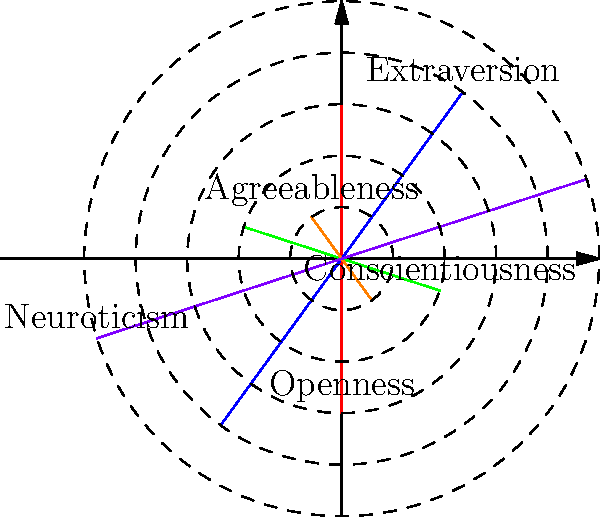In the given polar rose diagram representing the Big Five personality traits, which trait is represented by the largest petal, and what psychological implications might this have for an individual with such a prominent trait? To answer this question, we need to follow these steps:

1. Identify the traits represented in the diagram:
   The diagram shows five petals, each representing one of the Big Five personality traits:
   Openness, Conscientiousness, Extraversion, Agreeableness, and Neuroticism.

2. Determine the largest petal:
   By comparing the sizes of the petals, we can see that the purple petal, which represents Neuroticism, extends the furthest from the center and is therefore the largest.

3. Understand the implications of high Neuroticism:
   Neuroticism is associated with emotional instability and the tendency to experience negative emotions. A high score in Neuroticism might imply:

   a) Increased susceptibility to stress and anxiety
   b) Greater likelihood of experiencing mood swings
   c) Higher risk for developing mental health issues like depression or anxiety disorders
   d) Potentially more intense emotional responses to life events
   e) Possible difficulty in coping with challenging situations

4. Consider the professional implications:
   As a psychiatrist, recognizing a high Neuroticism score would be crucial for:

   a) Developing appropriate treatment plans
   b) Identifying potential risk factors for mental health issues
   c) Tailoring therapeutic approaches to address emotional regulation
   d) Helping the individual develop coping strategies for stress management
   e) Monitoring for signs of mood disorders or anxiety-related conditions

5. Contextualize within the overall personality profile:
   While Neuroticism is prominent, it's important to consider how it interacts with the other traits. For example, a high score in Conscientiousness might help mitigate some negative effects of high Neuroticism through better organization and self-discipline.
Answer: Neuroticism; increased emotional instability and vulnerability to stress. 